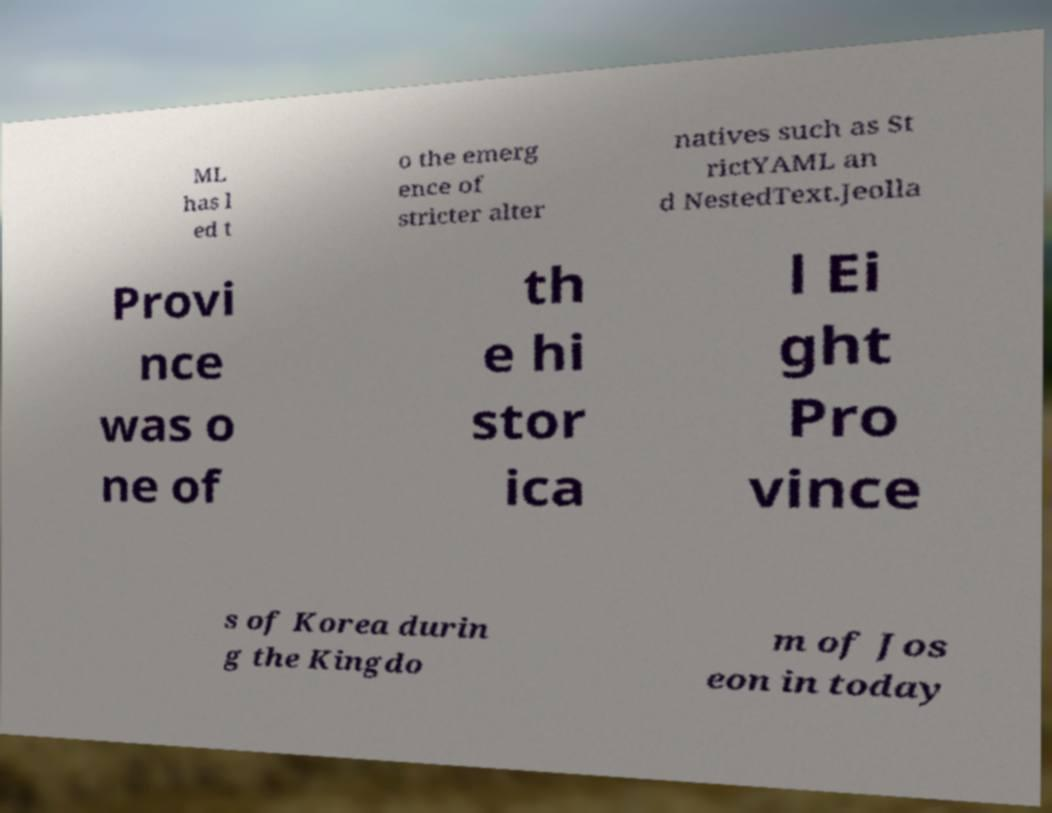Can you read and provide the text displayed in the image?This photo seems to have some interesting text. Can you extract and type it out for me? ML has l ed t o the emerg ence of stricter alter natives such as St rictYAML an d NestedText.Jeolla Provi nce was o ne of th e hi stor ica l Ei ght Pro vince s of Korea durin g the Kingdo m of Jos eon in today 